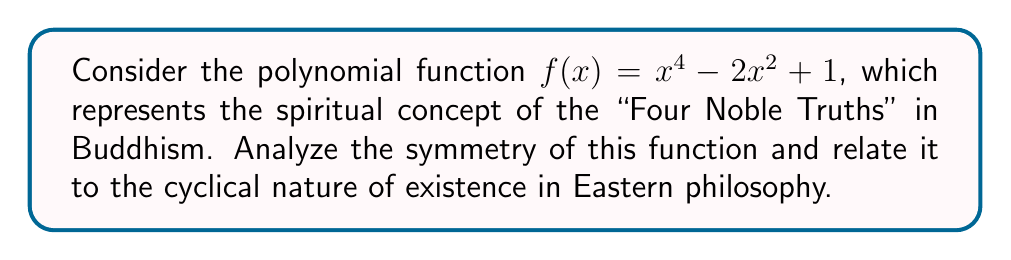Can you answer this question? 1) First, let's examine the polynomial function:
   $f(x) = x^4 - 2x^2 + 1$

2) To determine the symmetry, we need to check if $f(-x) = f(x)$ for all x:
   $f(-x) = (-x)^4 - 2(-x)^2 + 1$
          $= x^4 - 2x^2 + 1$
          $= f(x)$

3) Since $f(-x) = f(x)$, the function is even and symmetric about the y-axis.

4) The graph of this function is a W-shaped curve that is symmetric about the y-axis:

[asy]
import graph;
size(200,200);
real f(real x) {return x^4 - 2x^2 + 1;}
draw(graph(f,-2,2),blue);
axes((-2,-1),(2,3),Arrow);
label("x",(2,0),E);
label("y",(0,3),N);
[/asy]

5) This symmetry can be related to the cyclical nature of existence in Eastern philosophy:
   - The two valleys of the W represent the cycles of suffering (dukkha).
   - The central peak represents enlightenment or nirvana.
   - The symmetry reflects the balance and harmony in the universe.

6) The four turning points of the graph (two minima and two maxima) can be associated with the Four Noble Truths:
   - The existence of suffering
   - The origin of suffering
   - The cessation of suffering
   - The path to the cessation of suffering

7) The even nature of the function (containing only even powers of x) reflects the idea of karma, where actions have symmetric consequences.
Answer: The function is even and symmetric about the y-axis, reflecting cyclical existence and karmic balance in Eastern philosophy. 